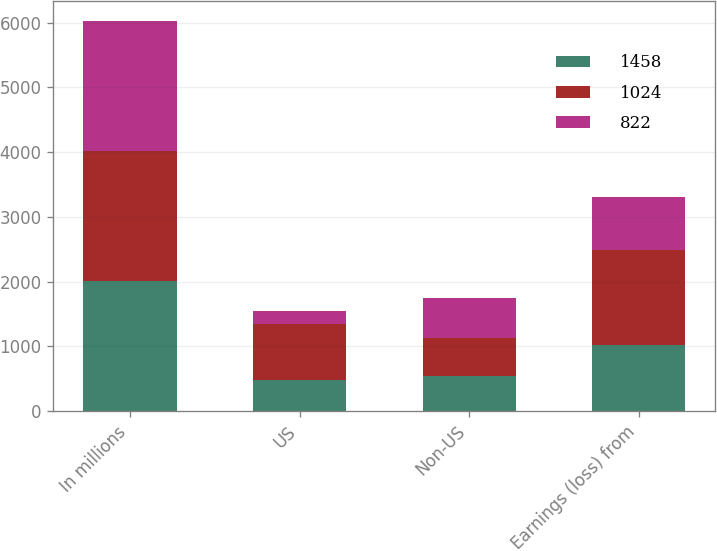Convert chart to OTSL. <chart><loc_0><loc_0><loc_500><loc_500><stacked_bar_chart><ecel><fcel>In millions<fcel>US<fcel>Non-US<fcel>Earnings (loss) from<nl><fcel>1458<fcel>2012<fcel>478<fcel>546<fcel>1024<nl><fcel>1024<fcel>2011<fcel>874<fcel>584<fcel>1458<nl><fcel>822<fcel>2010<fcel>198<fcel>624<fcel>822<nl></chart> 